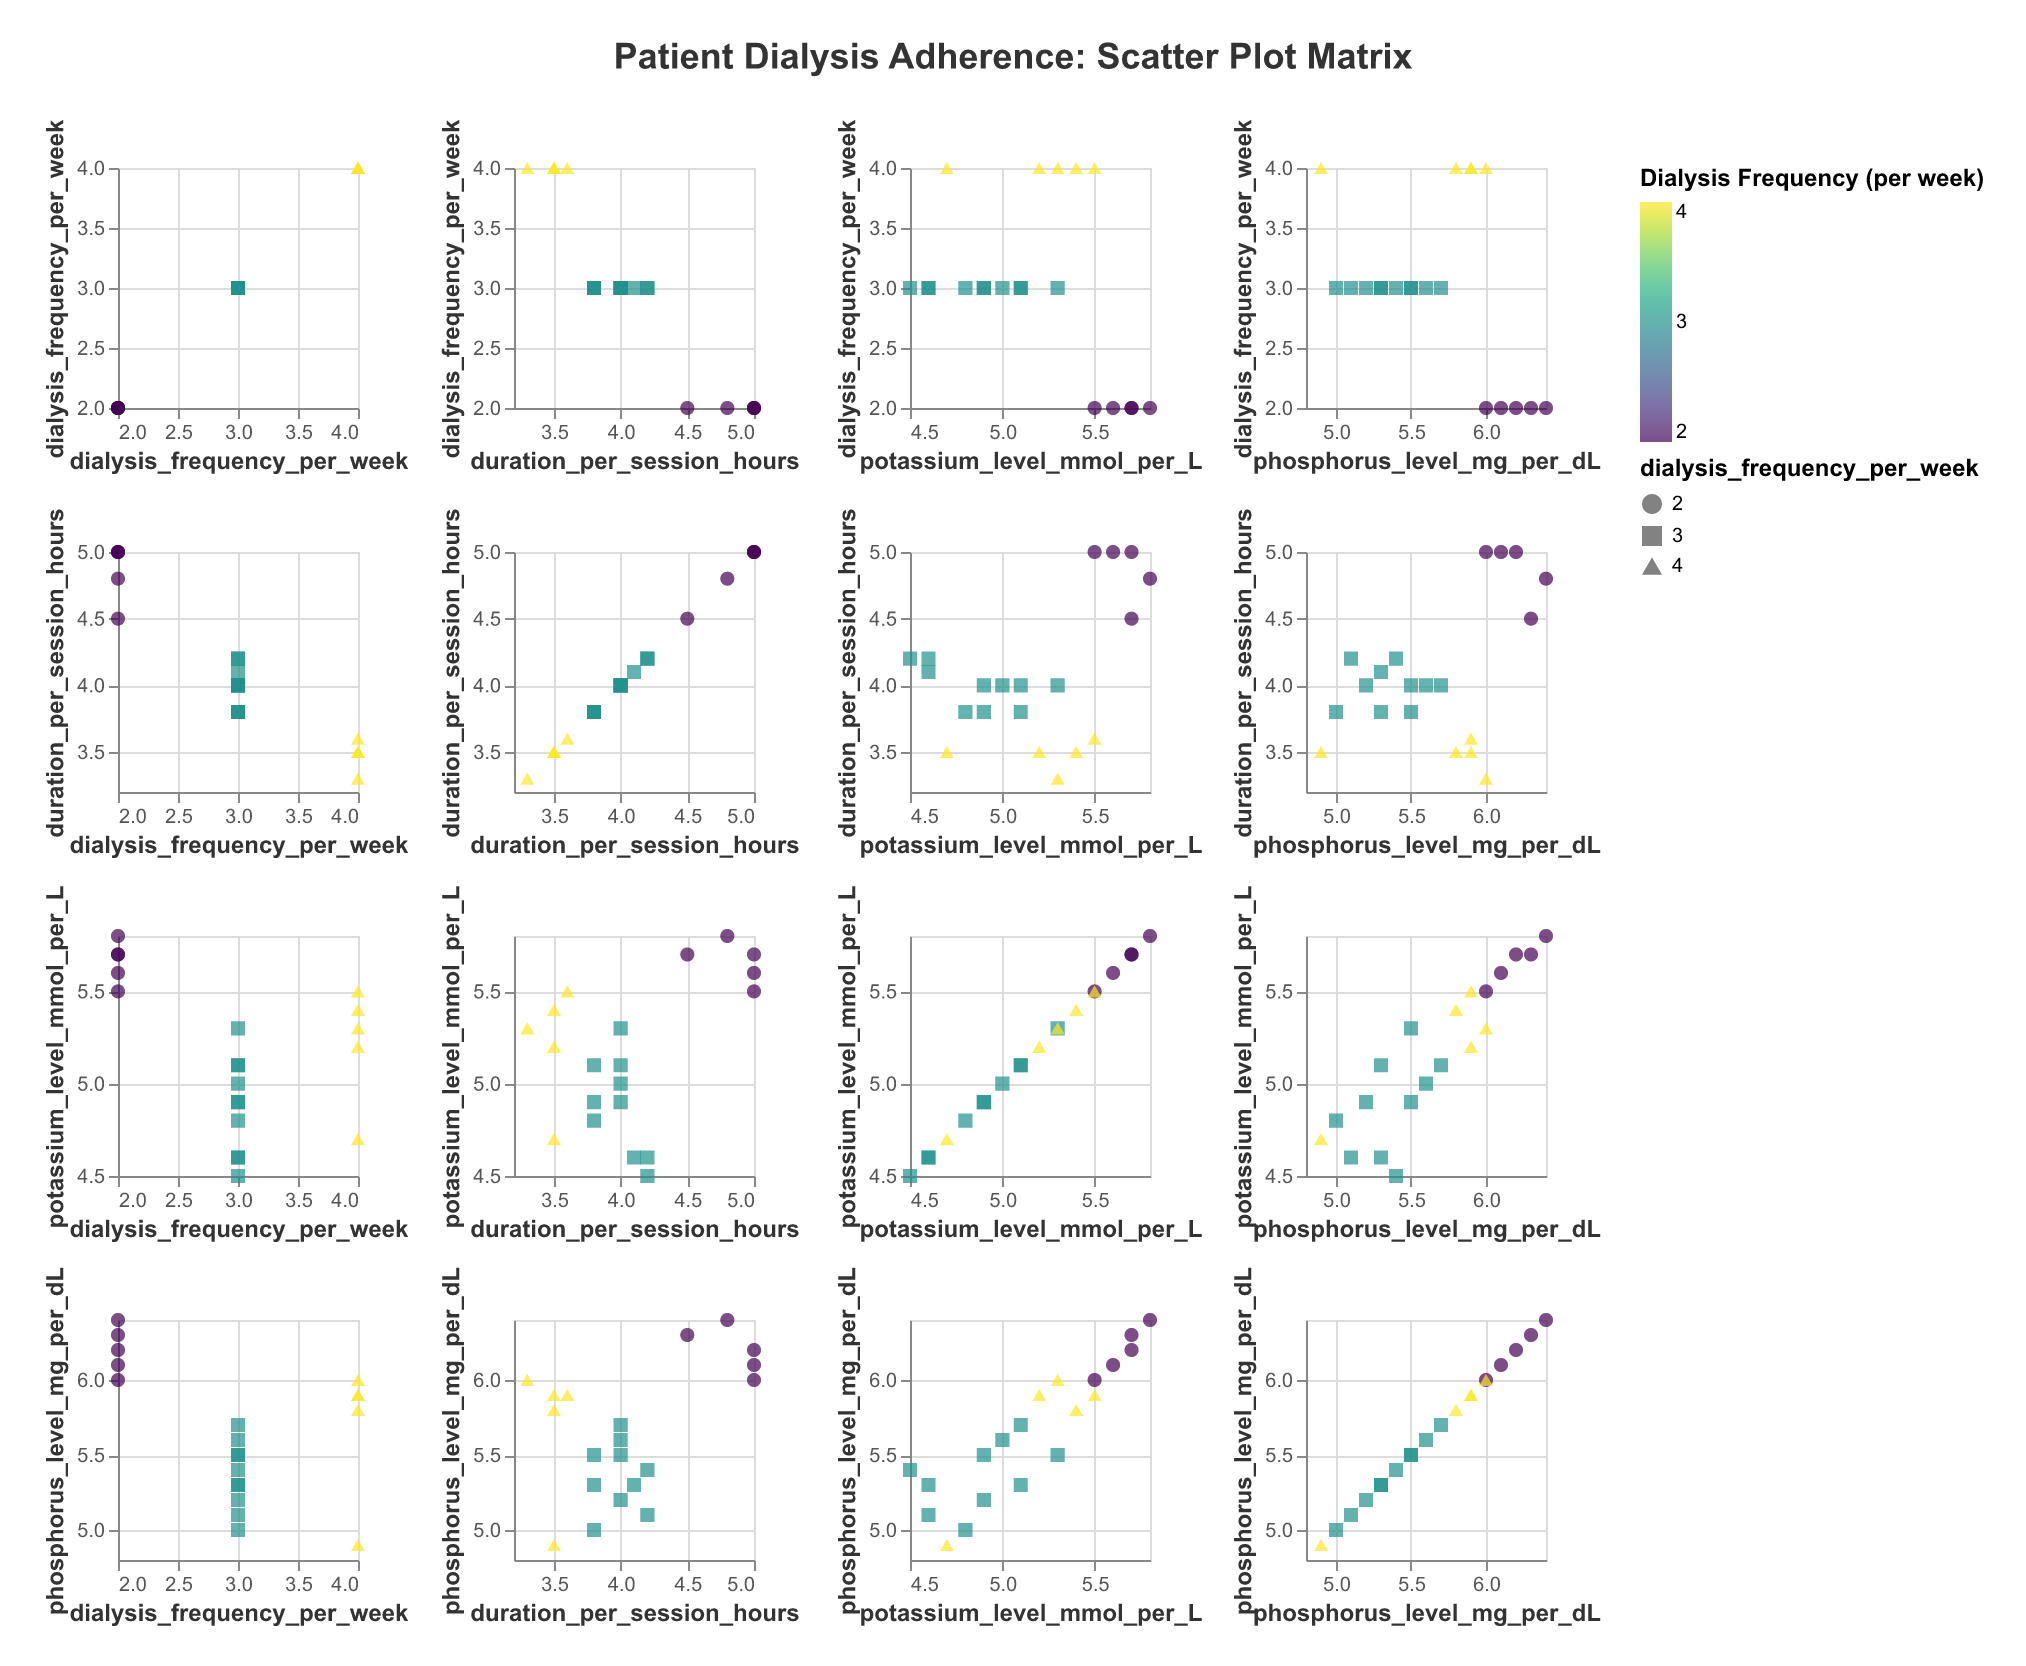How many patients have a dialysis frequency of 4 times per week? Count the number of points where the color corresponds to the color scale for '4 times per week' in the legend. There are five such patients.
Answer: 5 What is the average duration per session for patients with a potassium level over 5.5 mmol/L? Identify the points where the potassium level is over 5.5 mmol/L, and calculate the average of the corresponding duration values: (4.5 + 4.8 + 5 + 5 + 5 + 5)/6 = 4.72
Answer: 4.72 Which patient has the highest phosphorus level, and what is it? Look for the point with the highest phosphorus level on the phosphorus axis, the patient ID is available in the tooltip: Patient 14 with a phosphorus level of 6.4 mg/dL.
Answer: Patient 14, 6.4 mg/dL Is there a trend that higher dialysis frequency is associated with lower potassium levels? Inspect the scatter plots where dialysis frequency is plotted against potassium levels. Check if higher frequency generally plots near lower potassium levels.
Answer: No clear trend Compare the durations per session for patients with dialysis frequency of 2 and 4 times per week. Which group tends to have longer sessions on average? Identify the points for dialysis frequency of 2 and 4 times per week and compare. The averages: For frequency 2 - (5 + 4.5 + 5 + 4.8)/4 = 4.83, for frequency 4 - (3.5 + 3.5 + 3.5 + 3.3 + 3.6)/5 = 3.48
Answer: Patients with frequency of 2 times per week How does the variation in phosphorus levels compare between patients dialyzing 2 times and 3 times per week? Check the spread of phosphorus levels for points with frequencies of 2 and 3 in their respective subplots. Calculate the range: For frequency 2 - Max(6.4) - Min(6.0) = 0.4, for frequency 3 - Max(5.7) - Min(5.0) = 0.7
Answer: Greater variation for 3 times per week Which patient has the shortest dialysis session duration, and what is their potassium level? Find the point corresponding to the lowest duration value, check the tooltip for potassium level. Patient 17 with the duration of 3.3 hours and potassium level 5.3 mmol/L.
Answer: Patient 17, 5.3 mmol/L Do patients who dialyze more frequently show generally lower phosphorus levels? Analyze the plots where dialysis frequency is on one axis and phosphorus levels on the other. Look for a downward trend.
Answer: Vague trend What are the potassium levels for the patients who dialyze twice a week and have the longest session durations? Identify the patients with dialysis frequency of 2 and check their tooltip for duration and potassium levels.
Answer: 5.6, 5.7, 5.5, 5.7 mmol/L 